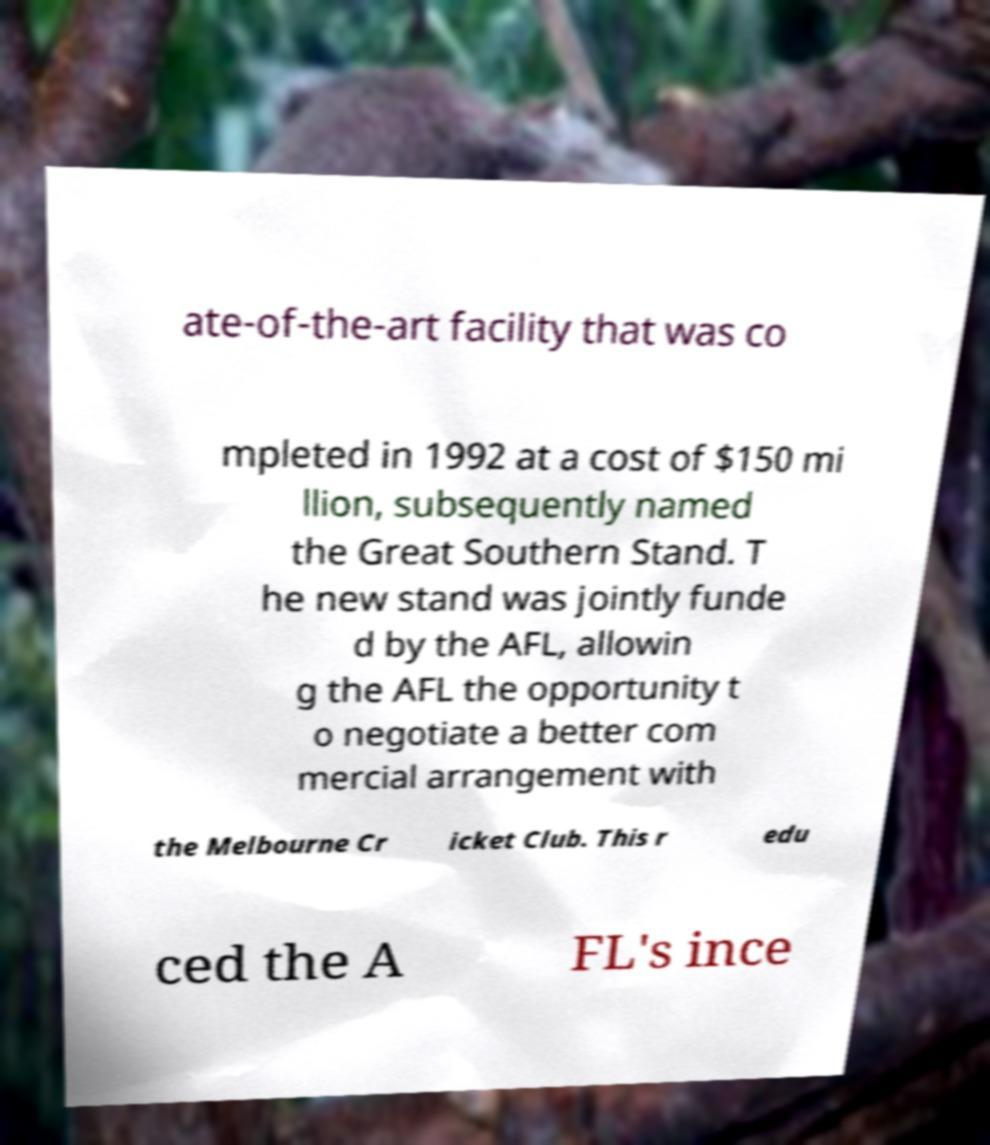I need the written content from this picture converted into text. Can you do that? ate-of-the-art facility that was co mpleted in 1992 at a cost of $150 mi llion, subsequently named the Great Southern Stand. T he new stand was jointly funde d by the AFL, allowin g the AFL the opportunity t o negotiate a better com mercial arrangement with the Melbourne Cr icket Club. This r edu ced the A FL's ince 